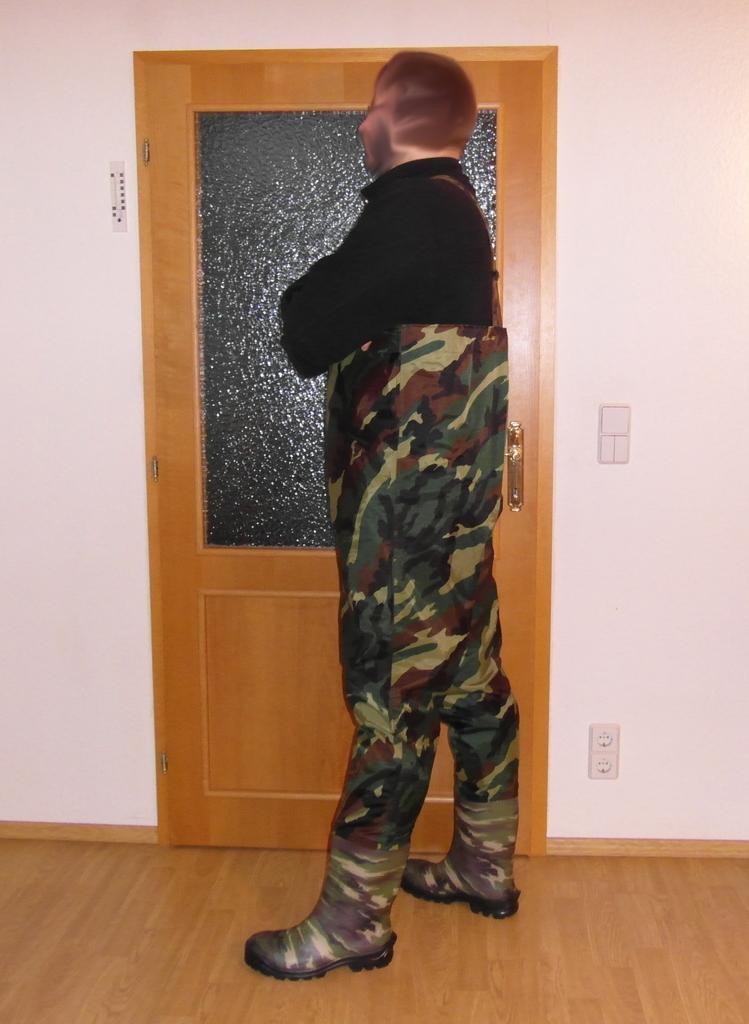Please provide a concise description of this image. In this image I can see a man is standing on the floor facing towards the left side. At the back of this man there is a door and a wall. 